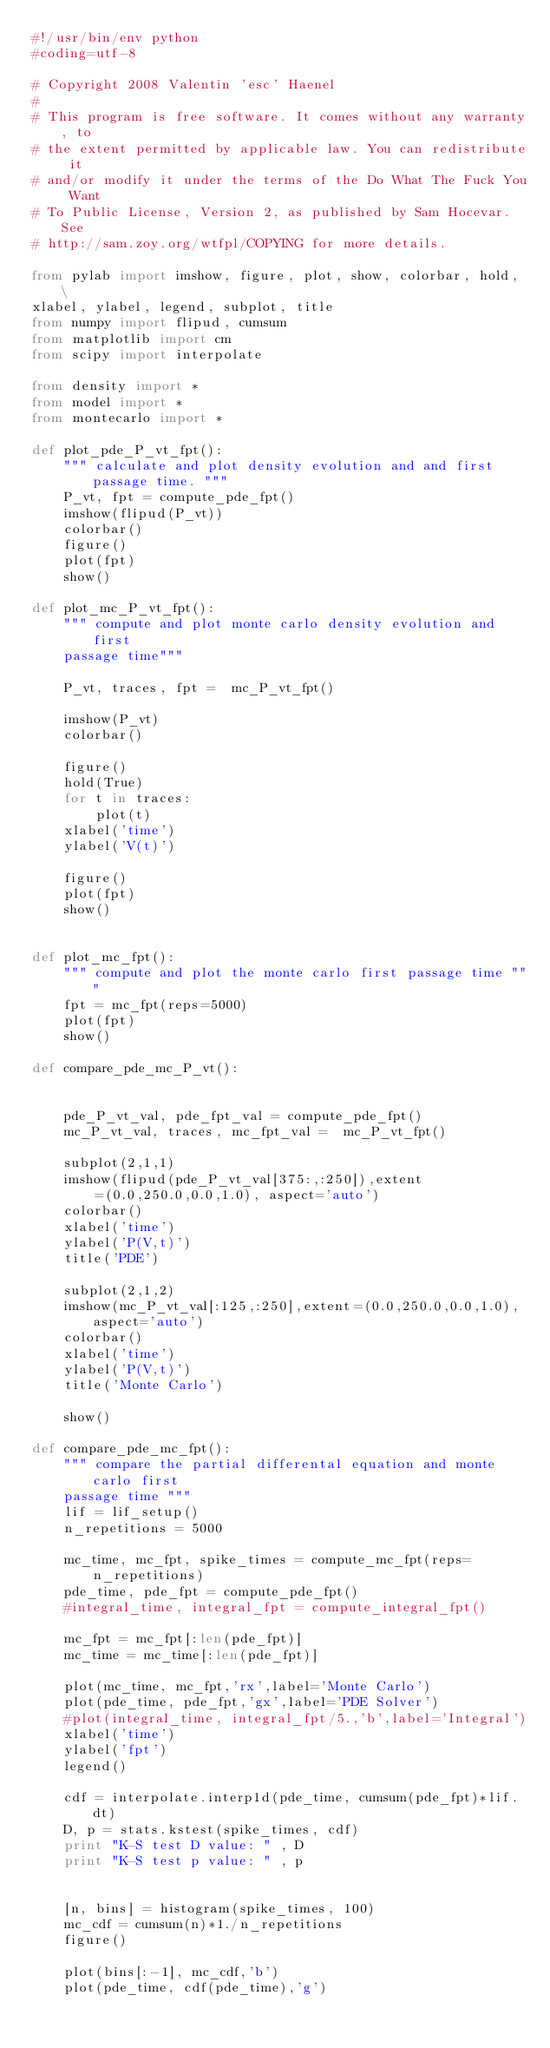Convert code to text. <code><loc_0><loc_0><loc_500><loc_500><_Python_>#!/usr/bin/env python
#coding=utf-8

# Copyright 2008 Valentin 'esc' Haenel
#
# This program is free software. It comes without any warranty, to
# the extent permitted by applicable law. You can redistribute it
# and/or modify it under the terms of the Do What The Fuck You Want
# To Public License, Version 2, as published by Sam Hocevar. See
# http://sam.zoy.org/wtfpl/COPYING for more details. 

from pylab import imshow, figure, plot, show, colorbar, hold, \
xlabel, ylabel, legend, subplot, title
from numpy import flipud, cumsum
from matplotlib import cm
from scipy import interpolate

from density import *
from model import *
from montecarlo import *

def plot_pde_P_vt_fpt():
    """ calculate and plot density evolution and and first passage time. """
    P_vt, fpt = compute_pde_fpt()
    imshow(flipud(P_vt))
    colorbar()
    figure()
    plot(fpt)
    show()

def plot_mc_P_vt_fpt():
    """ compute and plot monte carlo density evolution and first
    passage time"""

    P_vt, traces, fpt =  mc_P_vt_fpt()

    imshow(P_vt)
    colorbar()

    figure()
    hold(True)
    for t in traces:
        plot(t)
    xlabel('time')
    ylabel('V(t)')

    figure()
    plot(fpt)
    show()


def plot_mc_fpt():
    """ compute and plot the monte carlo first passage time """
    fpt = mc_fpt(reps=5000)
    plot(fpt)
    show()

def compare_pde_mc_P_vt():


    pde_P_vt_val, pde_fpt_val = compute_pde_fpt()
    mc_P_vt_val, traces, mc_fpt_val =  mc_P_vt_fpt()

    subplot(2,1,1)
    imshow(flipud(pde_P_vt_val[375:,:250]),extent=(0.0,250.0,0.0,1.0), aspect='auto')
    colorbar()
    xlabel('time')
    ylabel('P(V,t)')
    title('PDE')

    subplot(2,1,2)
    imshow(mc_P_vt_val[:125,:250],extent=(0.0,250.0,0.0,1.0), aspect='auto')
    colorbar()
    xlabel('time')
    ylabel('P(V,t)')
    title('Monte Carlo')

    show()
 
def compare_pde_mc_fpt():
    """ compare the partial differental equation and monte carlo first
    passage time """
    lif = lif_setup()
    n_repetitions = 5000

    mc_time, mc_fpt, spike_times = compute_mc_fpt(reps=n_repetitions)
    pde_time, pde_fpt = compute_pde_fpt()
    #integral_time, integral_fpt = compute_integral_fpt()
    
    mc_fpt = mc_fpt[:len(pde_fpt)]
    mc_time = mc_time[:len(pde_fpt)]

    plot(mc_time, mc_fpt,'rx',label='Monte Carlo')
    plot(pde_time, pde_fpt,'gx',label='PDE Solver')
    #plot(integral_time, integral_fpt/5.,'b',label='Integral')
    xlabel('time')
    ylabel('fpt')
    legend()

    cdf = interpolate.interp1d(pde_time, cumsum(pde_fpt)*lif.dt)
    D, p = stats.kstest(spike_times, cdf)
    print "K-S test D value: " , D
    print "K-S test p value: " , p


    [n, bins] = histogram(spike_times, 100)
    mc_cdf = cumsum(n)*1./n_repetitions
    figure()
    
    plot(bins[:-1], mc_cdf,'b')
    plot(pde_time, cdf(pde_time),'g')</code> 